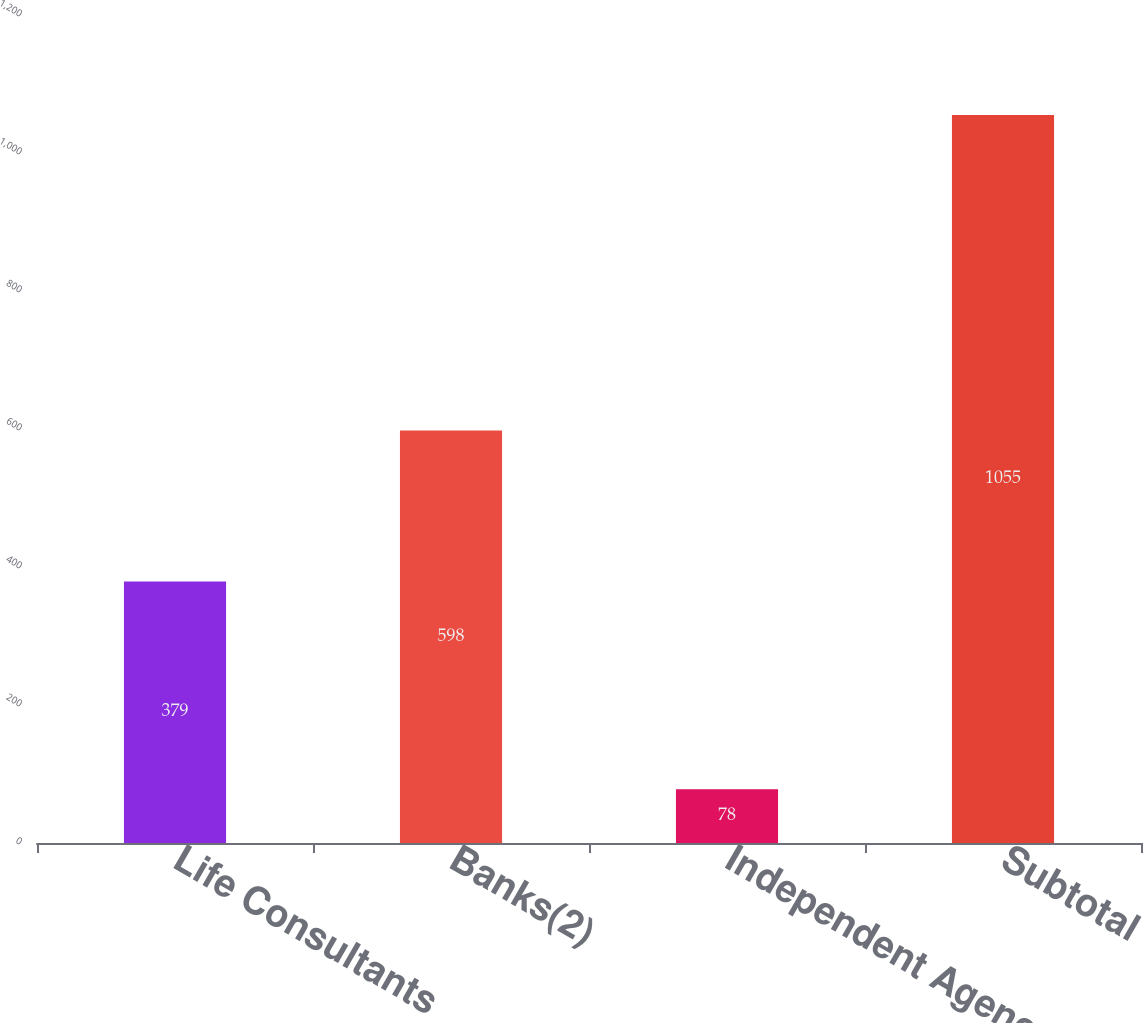<chart> <loc_0><loc_0><loc_500><loc_500><bar_chart><fcel>Life Consultants<fcel>Banks(2)<fcel>Independent Agency<fcel>Subtotal<nl><fcel>379<fcel>598<fcel>78<fcel>1055<nl></chart> 